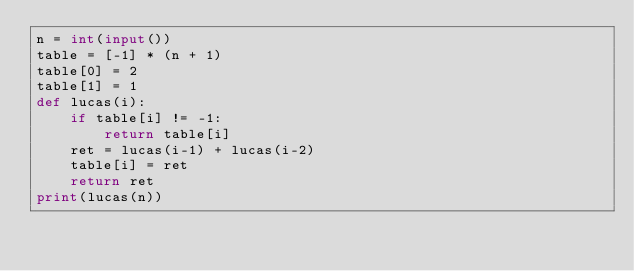Convert code to text. <code><loc_0><loc_0><loc_500><loc_500><_Python_>n = int(input())
table = [-1] * (n + 1)
table[0] = 2
table[1] = 1
def lucas(i):
    if table[i] != -1:
        return table[i]
    ret = lucas(i-1) + lucas(i-2)
    table[i] = ret
    return ret
print(lucas(n))</code> 